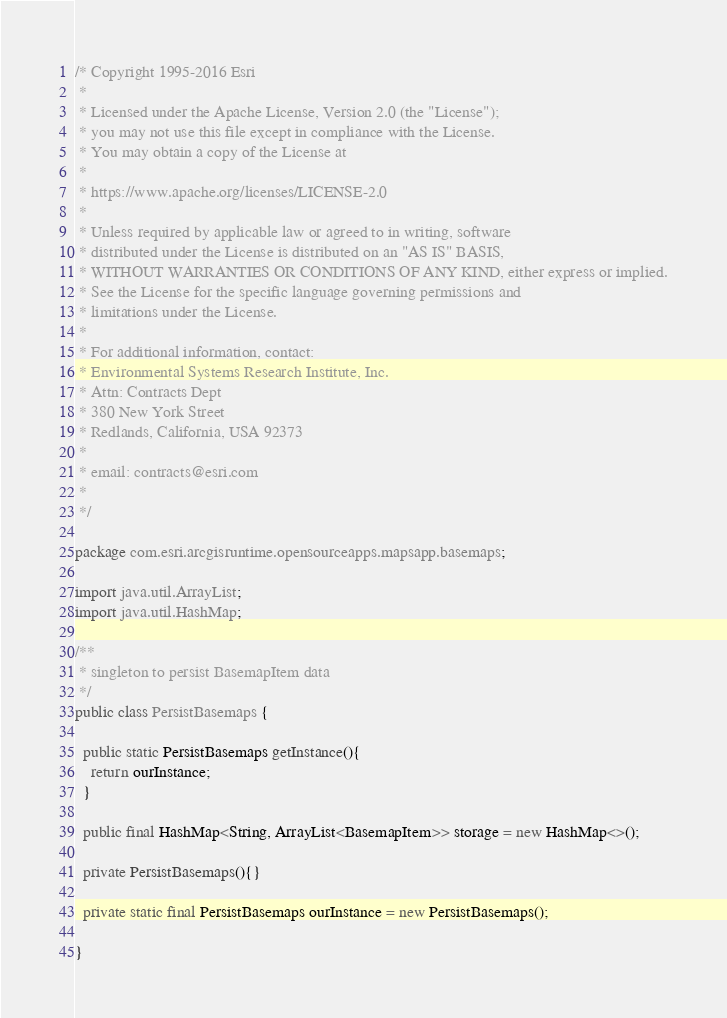Convert code to text. <code><loc_0><loc_0><loc_500><loc_500><_Java_>/* Copyright 1995-2016 Esri
 *
 * Licensed under the Apache License, Version 2.0 (the "License");
 * you may not use this file except in compliance with the License.
 * You may obtain a copy of the License at
 *
 * https://www.apache.org/licenses/LICENSE-2.0
 *
 * Unless required by applicable law or agreed to in writing, software
 * distributed under the License is distributed on an "AS IS" BASIS,
 * WITHOUT WARRANTIES OR CONDITIONS OF ANY KIND, either express or implied.
 * See the License for the specific language governing permissions and
 * limitations under the License.
 *
 * For additional information, contact:
 * Environmental Systems Research Institute, Inc.
 * Attn: Contracts Dept
 * 380 New York Street
 * Redlands, California, USA 92373
 *
 * email: contracts@esri.com
 *
 */

package com.esri.arcgisruntime.opensourceapps.mapsapp.basemaps;

import java.util.ArrayList;
import java.util.HashMap;

/**
 * singleton to persist BasemapItem data
 */
public class PersistBasemaps {

  public static PersistBasemaps getInstance(){
    return ourInstance;
  }

  public final HashMap<String, ArrayList<BasemapItem>> storage = new HashMap<>();

  private PersistBasemaps(){}

  private static final PersistBasemaps ourInstance = new PersistBasemaps();

}</code> 